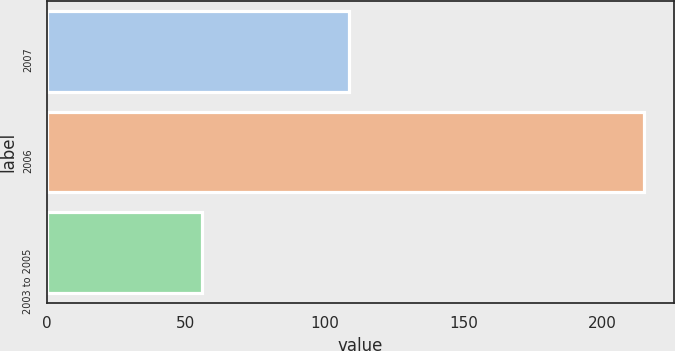Convert chart. <chart><loc_0><loc_0><loc_500><loc_500><bar_chart><fcel>2007<fcel>2006<fcel>2003 to 2005<nl><fcel>109<fcel>215<fcel>56<nl></chart> 